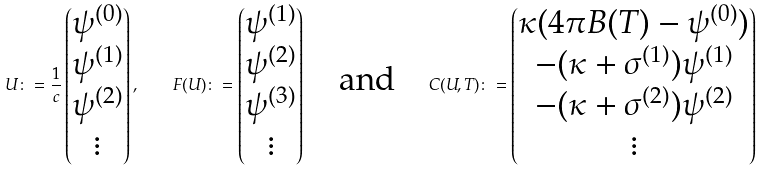<formula> <loc_0><loc_0><loc_500><loc_500>U \colon = \frac { 1 } { c } \left ( \begin{matrix} \psi ^ { ( 0 ) } \\ \psi ^ { ( 1 ) } \\ \psi ^ { ( 2 ) } \\ \vdots \end{matrix} \right ) , \quad F ( U ) \colon = \left ( \begin{matrix} \psi ^ { ( 1 ) } \\ \psi ^ { ( 2 ) } \\ \psi ^ { ( 3 ) } \\ \vdots \end{matrix} \right ) \quad \text {and} \quad C ( U , T ) \colon = \left ( \begin{matrix} \kappa ( 4 \pi B ( T ) - \psi ^ { ( 0 ) } ) \\ - ( \kappa + \sigma ^ { ( 1 ) } ) \psi ^ { ( 1 ) } \\ - ( \kappa + \sigma ^ { ( 2 ) } ) \psi ^ { ( 2 ) } \\ \vdots \end{matrix} \right )</formula> 